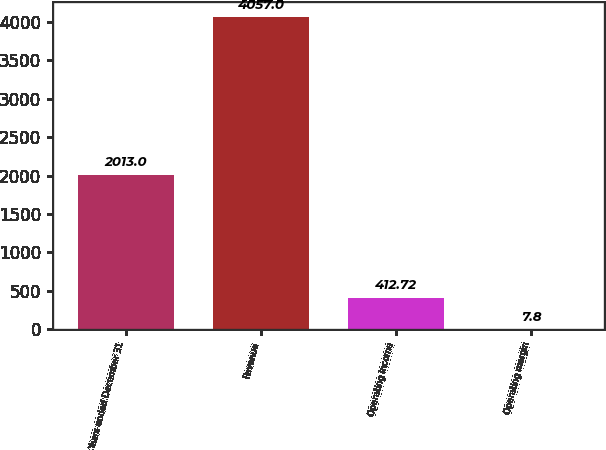<chart> <loc_0><loc_0><loc_500><loc_500><bar_chart><fcel>Years ended December 31<fcel>Revenue<fcel>Operating income<fcel>Operating margin<nl><fcel>2013<fcel>4057<fcel>412.72<fcel>7.8<nl></chart> 